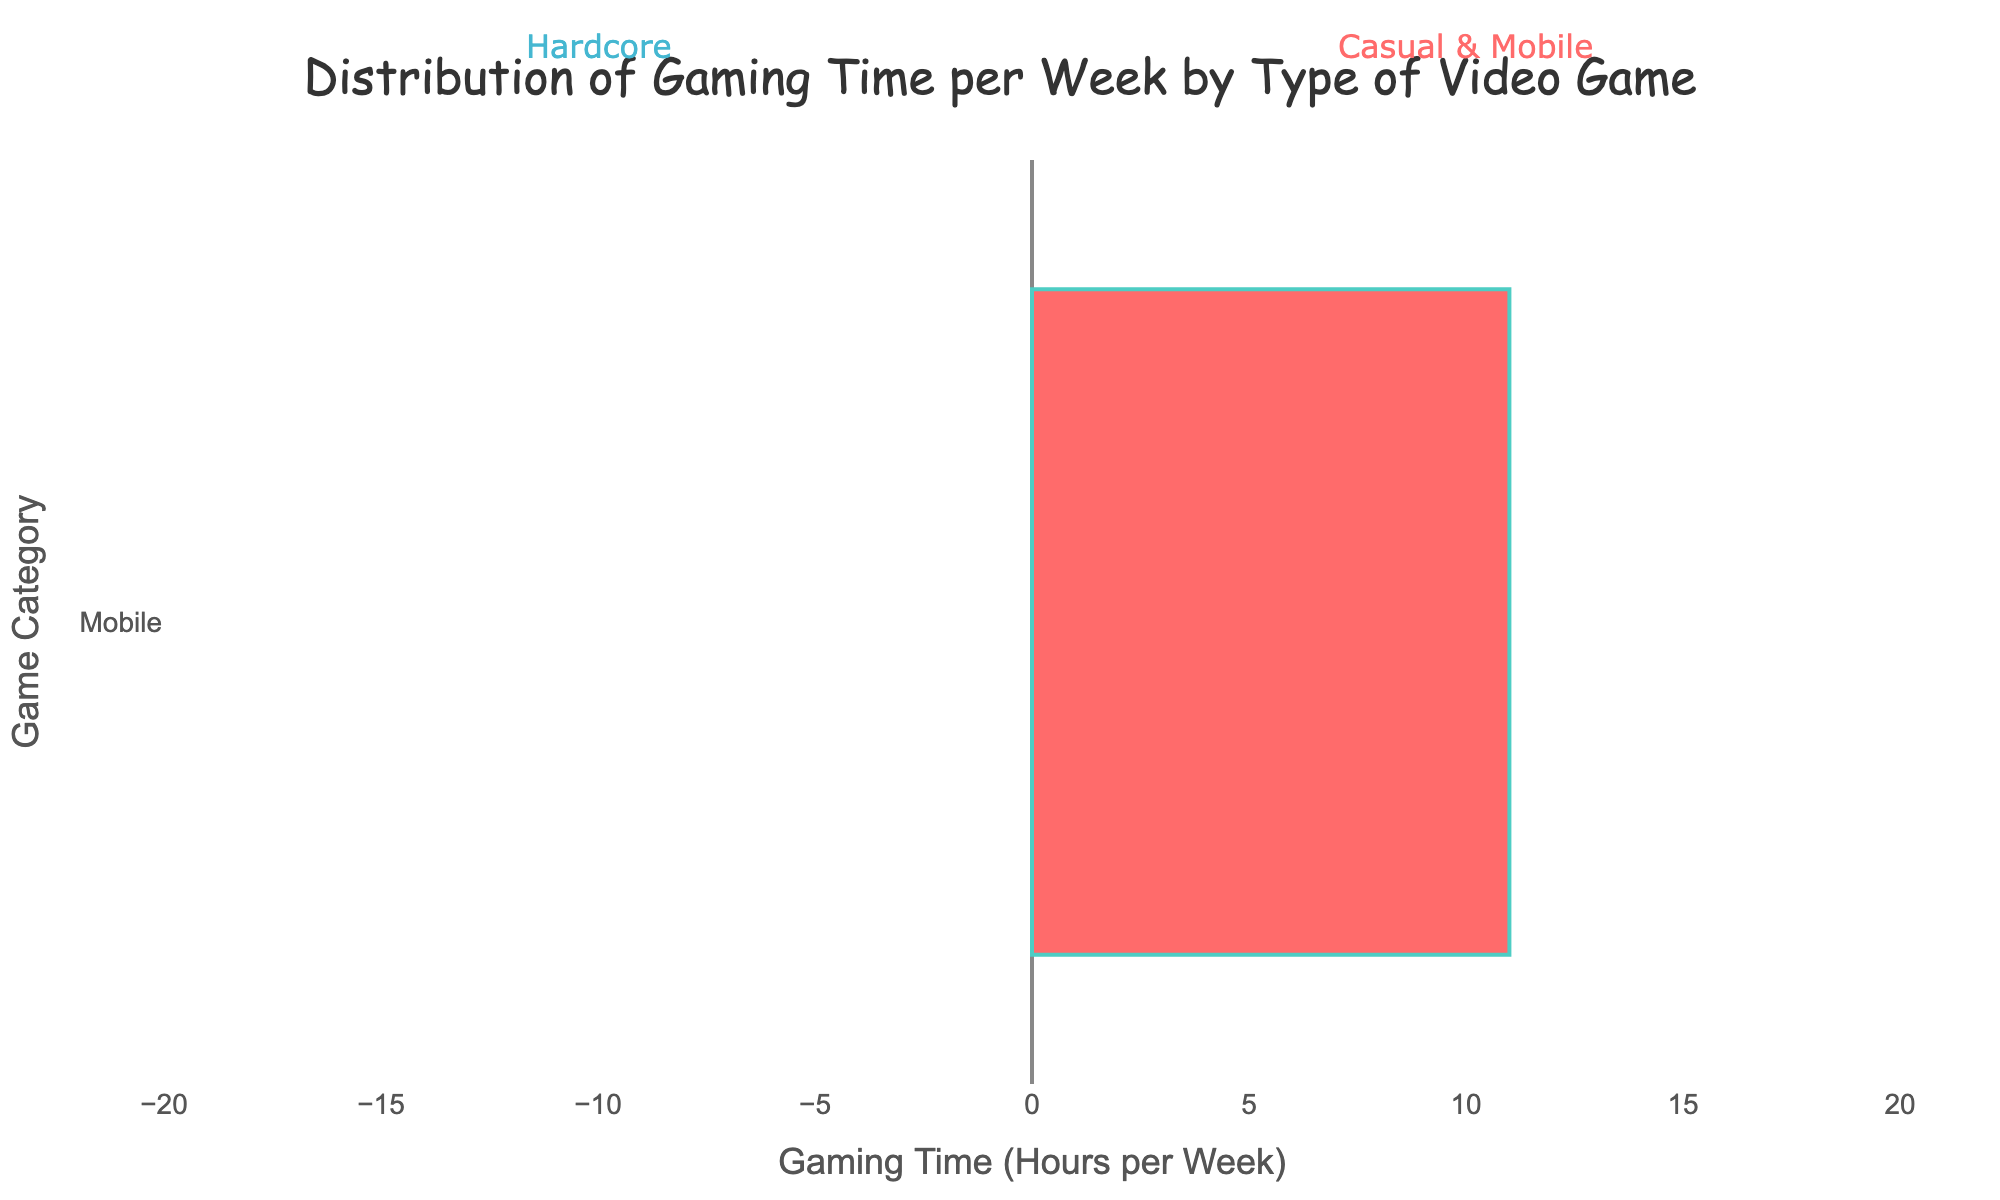What's the total gaming time spent on all categories and types combined? Sum all the gaming times for casual, hardcore, and mobile types. For casual: 8 + 5 + 6 + 6 = 25 hours. For hardcore: 15 + 12 + 18 + 13 = 58 hours. For mobile: 7 + 10 + 9 + 11 = 37 hours. Total: 25 + 58 + 37 = 120 hours
Answer: 120 hours Which type of video game has the highest cumulative gaming time? Add up the total gaming time for each type: Casual (25 hours), Hardcore (58 hours), and Mobile (37 hours). Hardcore has the highest cumulative gaming time.
Answer: Hardcore What is the difference in gaming time between the top two games in the Hardcore category? The top two games in the Hardcore category are MOBA (18 hours) and RPG (15 hours). The difference is 18 - 15 = 3 hours.
Answer: 3 hours Which game category has the highest individual gaming time? Identify the game with the highest gaming time regardless of type. The highest is MOBA (Hardcore) at 18 hours.
Answer: MOBA How many hours more do Hardcore gamers play than Mobile gamers? Total hours for Hardcore: 15 + 12 + 18 + 13 = 58 hours. Total hours for Mobile: 7 + 10 + 9 + 11 = 37 hours. Difference: 58 - 37 = 21 hours.
Answer: 21 hours Which Casual game has the least gaming time, and how much is it? The Casual games and their times are: Action (8 hours), Puzzle (5 hours), Simulation (6 hours), Adventure (6 hours). The least is Puzzle at 5 hours.
Answer: Puzzle, 5 hours If the gaming time for Simulation under Casual was increased by 4 hours, what would be the new total gaming time for Casual games? Current total for Casual is 25 hours. Increasing Simulation time by 4 hours changes it from 6 to 10 hours. New total: 25 + 4 = 29 hours.
Answer: 29 hours What is the average gaming time for the Mobile category? Total hours for Mobile: 7 + 10 + 9 + 11 = 37 hours. There are 4 Mobile games. Average: 37 / 4 = 9.25 hours.
Answer: 9.25 hours Compare the gaming times of Puzzle games in Casual and Mobile categories. Which has more and by how much? Casual Puzzle: 5 hours, Mobile Puzzle: 10 hours. Difference: 10 - 5 = 5 hours, with Mobile Puzzle having more.
Answer: Mobile Puzzle by 5 hours 